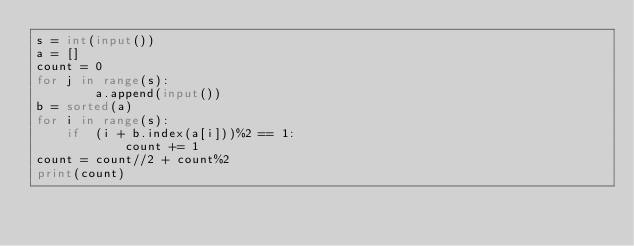<code> <loc_0><loc_0><loc_500><loc_500><_Python_>s = int(input())
a = []
count = 0
for j in range(s):
        a.append(input())
b = sorted(a)
for i in range(s):
    if  (i + b.index(a[i]))%2 == 1:
            count += 1
count = count//2 + count%2
print(count)</code> 